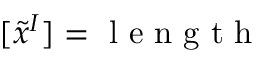Convert formula to latex. <formula><loc_0><loc_0><loc_500><loc_500>[ \tilde { x } ^ { I } ] = l e n g t h</formula> 